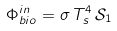Convert formula to latex. <formula><loc_0><loc_0><loc_500><loc_500>\Phi _ { b i o } ^ { i n } = \sigma \, T _ { s } ^ { 4 } \, \mathcal { S } _ { 1 }</formula> 